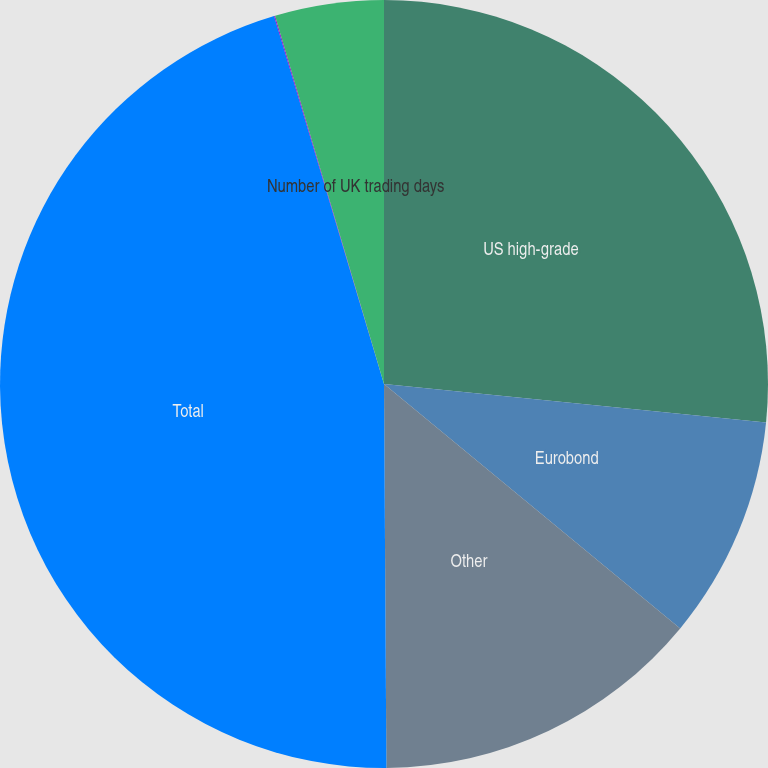Convert chart to OTSL. <chart><loc_0><loc_0><loc_500><loc_500><pie_chart><fcel>US high-grade<fcel>Eurobond<fcel>Other<fcel>Total<fcel>Number of US trading days<fcel>Number of UK trading days<nl><fcel>26.6%<fcel>9.38%<fcel>13.92%<fcel>45.48%<fcel>0.04%<fcel>4.58%<nl></chart> 